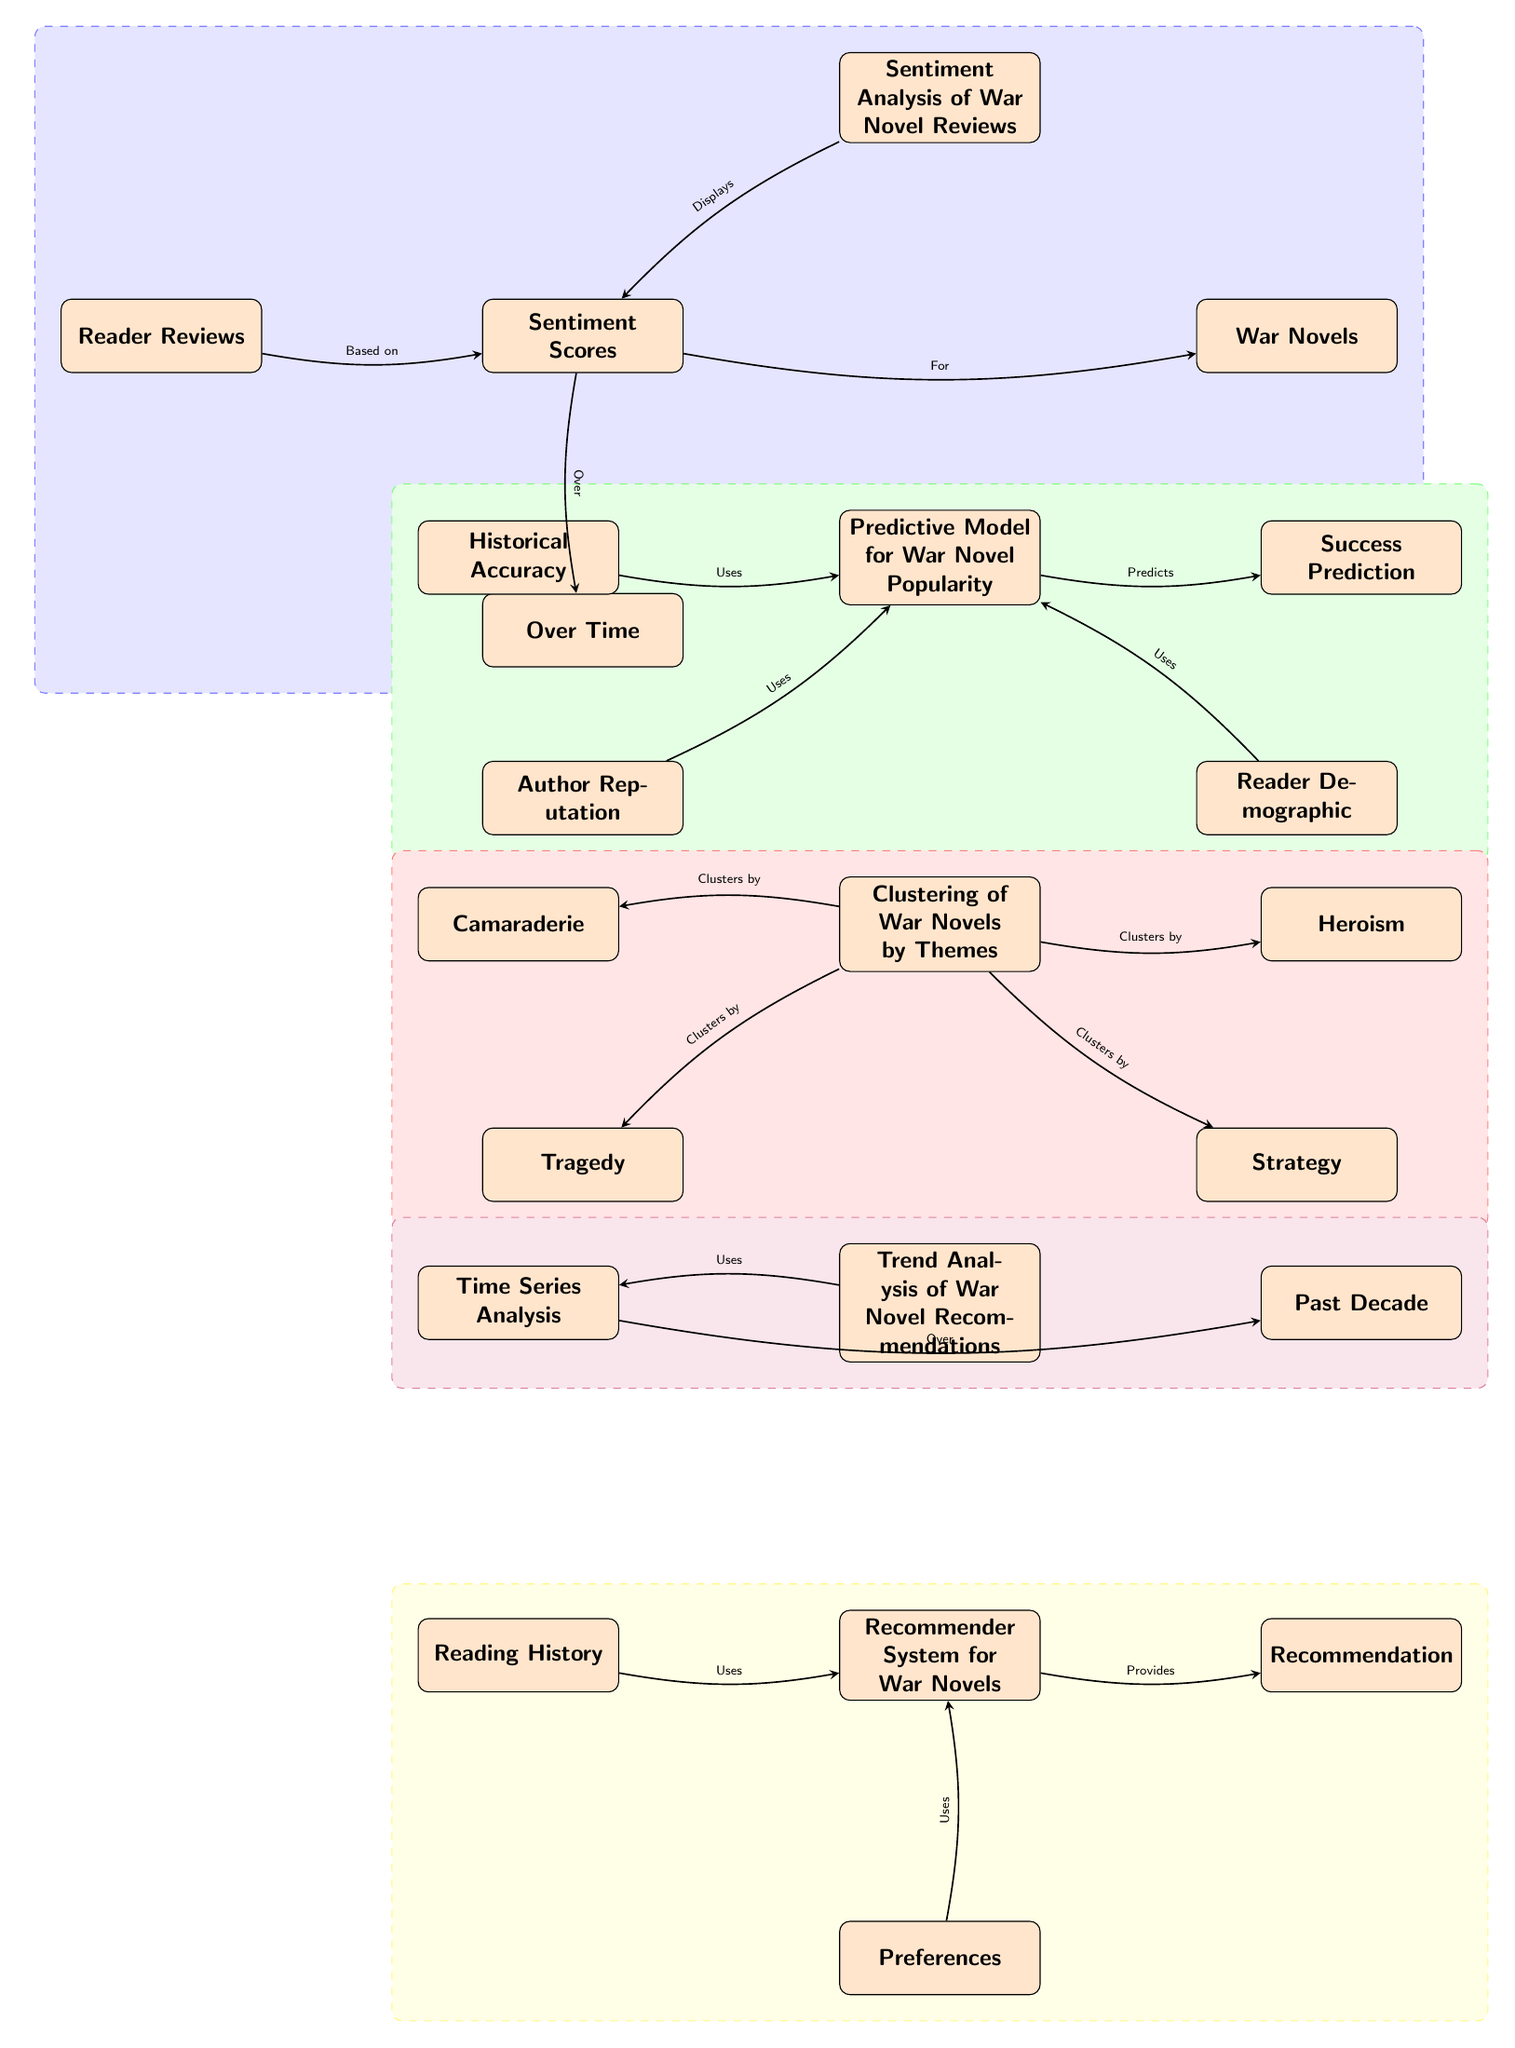What is the first node in the diagram? The first node in the diagram is titled "Sentiment Analysis of War Novel Reviews." This is identified by its position at the top of the diagram, serving as the focal point for several branches below it.
Answer: Sentiment Analysis of War Novel Reviews How many primary sections are there in the diagram? The diagram consists of five primary sections, each represented by a different algorithm or analysis related to war novels: Sentiment Analysis, Predictive Model, Clustering, Trend Analysis, and Recommender System. Each section is visually separated by colored backgrounds.
Answer: 5 What node uses Reader Demographic? The node "Predictive Model for War Novel Popularity" uses "Reader Demographic" as an input factor. This is indicated by the directed edge leading from "Reader Demographic" to the "Predictive Model."
Answer: Predictive Model for War Novel Popularity Which theme clusters together with Tragedy in the diagram? "Strategy" and "Camaraderie" cluster with "Tragedy" under the node "Clustering of War Novels by Themes." This is determined by tracing the edges from "Clustering of War Novels by Themes" to the individual themes.
Answer: Strategy, Camaraderie What is the relationship between Sentiment Scores and War Novels? The relationship is defined by the edge showing that Sentiment Scores are calculated "For" War Novels. This indicates that the sentiment scores are derived from the evaluation of various war novels based on their corresponding reader reviews.
Answer: For What does the Recommender System provide? The Recommender System provides "Recommendation." This is indicated by the directed edge leading from the Recommender System node to the Recommendation node, illustrating its output function.
Answer: Recommendation Which node does the Time Series Analysis influence? The "Trend Analysis of War Novel Recommendations" is influenced by the "Time Series Analysis." The relationship is indicated by the edge flowing from Time Series to Trend Analysis, denoting that the latter utilizes the former's data.
Answer: Trend Analysis of War Novel Recommendations What kind of model is depicted in the second section of the diagram? The second section of the diagram illustrates a "Predictive Model for War Novel Popularity." This is determined from the title of the node in the section's heading, which describes its focus on predicting popularity.
Answer: Predictive Model for War Novel Popularity How many themes are represented in the Clustering of War Novels by Themes? There are four themes represented: Camaraderie, Tragedy, Strategy, and Heroism. This count can be confirmed by the number of nodes connected to the Clustering node, each representing a unique theme.
Answer: 4 